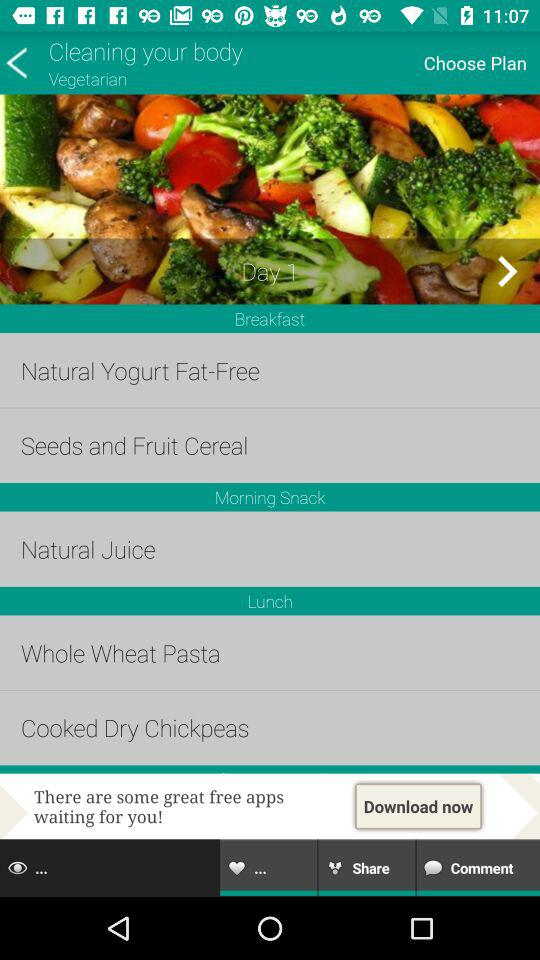What does the morning snack includes? The morning snack includes "Natural Juice". 